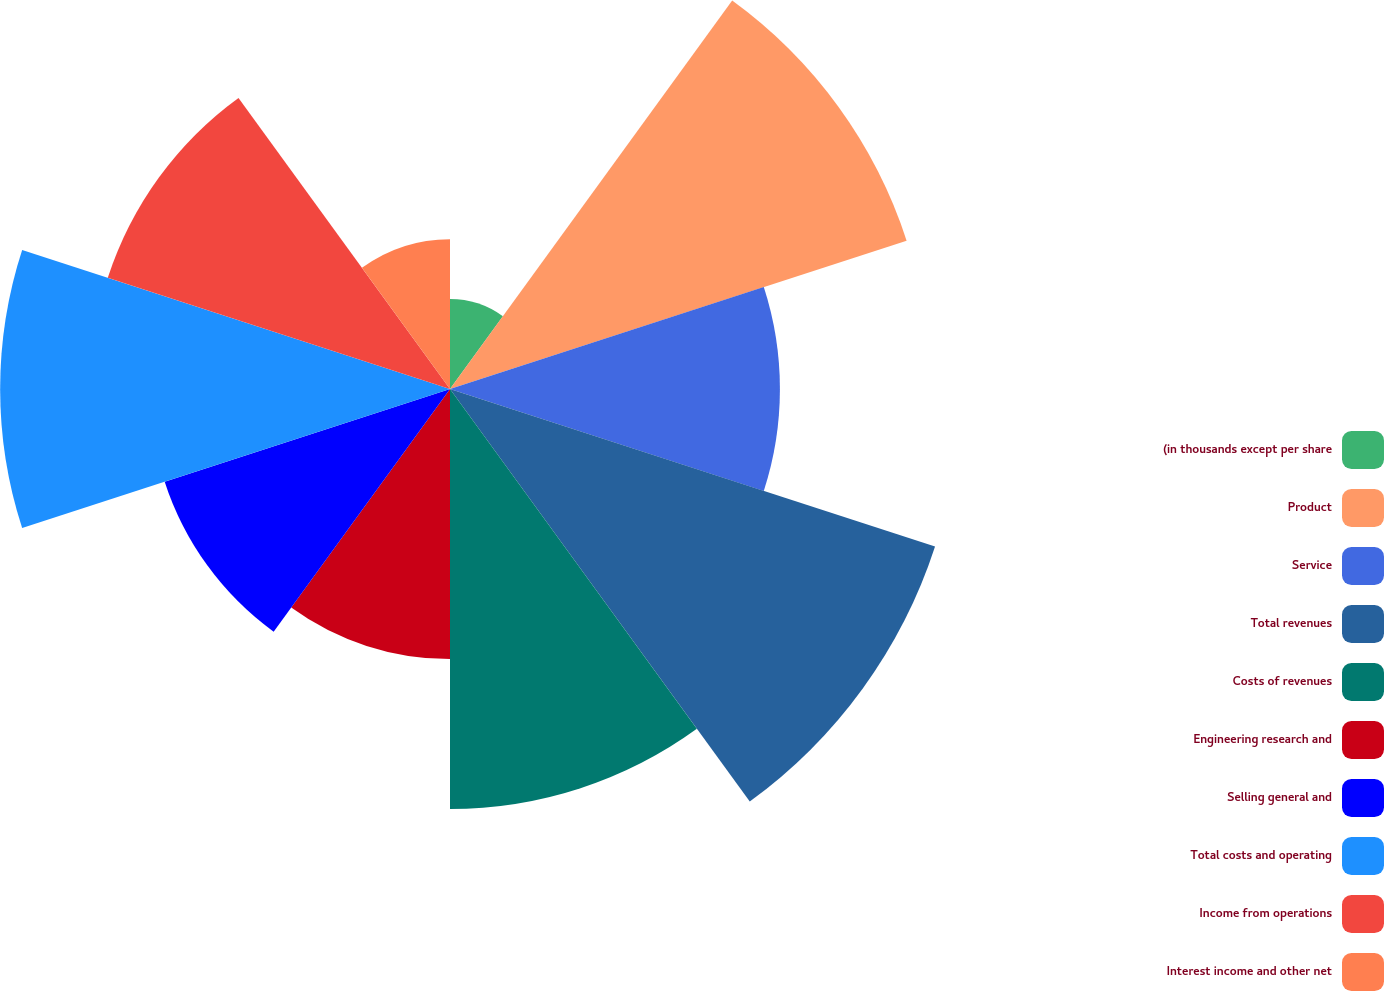Convert chart. <chart><loc_0><loc_0><loc_500><loc_500><pie_chart><fcel>(in thousands except per share<fcel>Product<fcel>Service<fcel>Total revenues<fcel>Costs of revenues<fcel>Engineering research and<fcel>Selling general and<fcel>Total costs and operating<fcel>Income from operations<fcel>Interest income and other net<nl><fcel>2.68%<fcel>14.29%<fcel>9.82%<fcel>15.18%<fcel>12.5%<fcel>8.04%<fcel>8.93%<fcel>13.39%<fcel>10.71%<fcel>4.46%<nl></chart> 